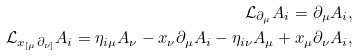<formula> <loc_0><loc_0><loc_500><loc_500>\mathcal { L } _ { \partial _ { \mu } } A _ { i } = \partial _ { \mu } A _ { i } , \\ \mathcal { L } _ { x _ { [ \mu } \partial _ { \nu ] } } A _ { i } = \eta _ { i \mu } A _ { \nu } - x _ { \nu } \partial _ { \mu } A _ { i } - \eta _ { i \nu } A _ { \mu } + x _ { \mu } \partial _ { \nu } A _ { i } ,</formula> 